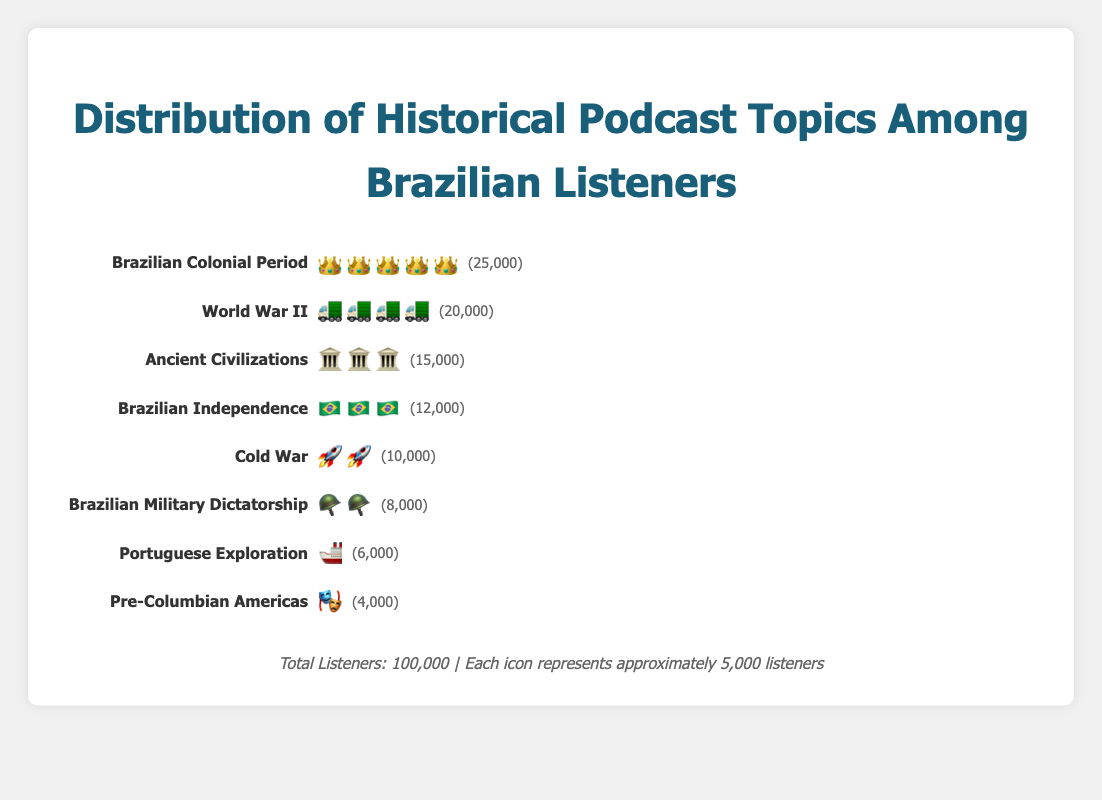Which historical podcast topic is the most popular among Brazilian listeners? The most popular topic is represented by the one with the largest number of icons. The "Brazilian Colonial Period" has 5 crown icons, which indicates it has the most listeners.
Answer: Brazilian Colonial Period How many listeners are interested in Ancient Civilizations? Each icon represents 5,000 listeners. There are 3 pyramid icons for Ancient Civilizations, so 3 * 5,000 equals 15,000 listeners.
Answer: 15,000 What percentage of the total listeners are interested in World War II podcasts? World War II has 4 tank icons, representing 20,000 listeners. Given that the total number of listeners is 100,000, the percentage is (20,000/100,000) * 100%.
Answer: 20% Which topics have fewer than 10,000 listeners? By counting the icons, we see that "Brazilian Military Dictatorship" has 2 soldier icons (8,000 listeners), "Portuguese Exploration" has 1 ship icon (6,000 listeners), and "Pre-Columbian Americas" has 1 mask icon (4,000 listeners).
Answer: Brazilian Military Dictatorship, Portuguese Exploration, Pre-Columbian Americas How many total icons are used in the figure, and what does this represent in terms of listeners? Adding the icons per category: 5 (crown) + 4 (tank) + 3 (pyramid) + 3 (flag) + 2 (missile) + 2 (soldier) + 1 (ship) + 1 (mask) = 21 icons. Each icon equals 5,000 listeners, so 21 * 5,000 equals 105,000 listeners, which seems higher than expected due to rounding or approximate representation.
Answer: 21 icons representing approximately 105,000 listeners Compare the listeners interested in the Cold War with those interested in Brazilian Independence. Cold War has 2 missile icons (10,000 listeners) and Brazilian Independence has 3 flag icons (15,000 listeners). Therefore, Brazilian Independence has 5,000 more listeners than Cold War.
Answer: Brazilian Independence has 5,000 more listeners If each icon represents 5,000 listeners, how many more icons does the "Brazilian Colonial Period" have compared to "Pre-Columbian Americas"? Brazilian Colonial Period has 5 crown icons, and Pre-Columbian Americas has 1 mask icon. The difference is 5 - 1 = 4 icons.
Answer: 4 more icons What is the total number of listeners for topics related to Brazilian history (Brazilian Colonial Period, Brazilian Independence, Brazilian Military Dictatorship, Portuguese Exploration)? Brazilian Colonial Period (25,000 listeners), Brazilian Independence (12,000 listeners), Brazilian Military Dictatorship (8,000 listeners), Portuguese Exploration (6,000 listeners). Total: 25,000 + 12,000 + 8,000 + 6,000 = 51,000 listeners.
Answer: 51,000 listeners Which category has the least interest among the listeners, and how can you tell? The category with the fewest listeners is "Pre-Columbian Americas," represented by a single mask icon, which equals 4,000 listeners.
Answer: Pre-Columbian Americas 